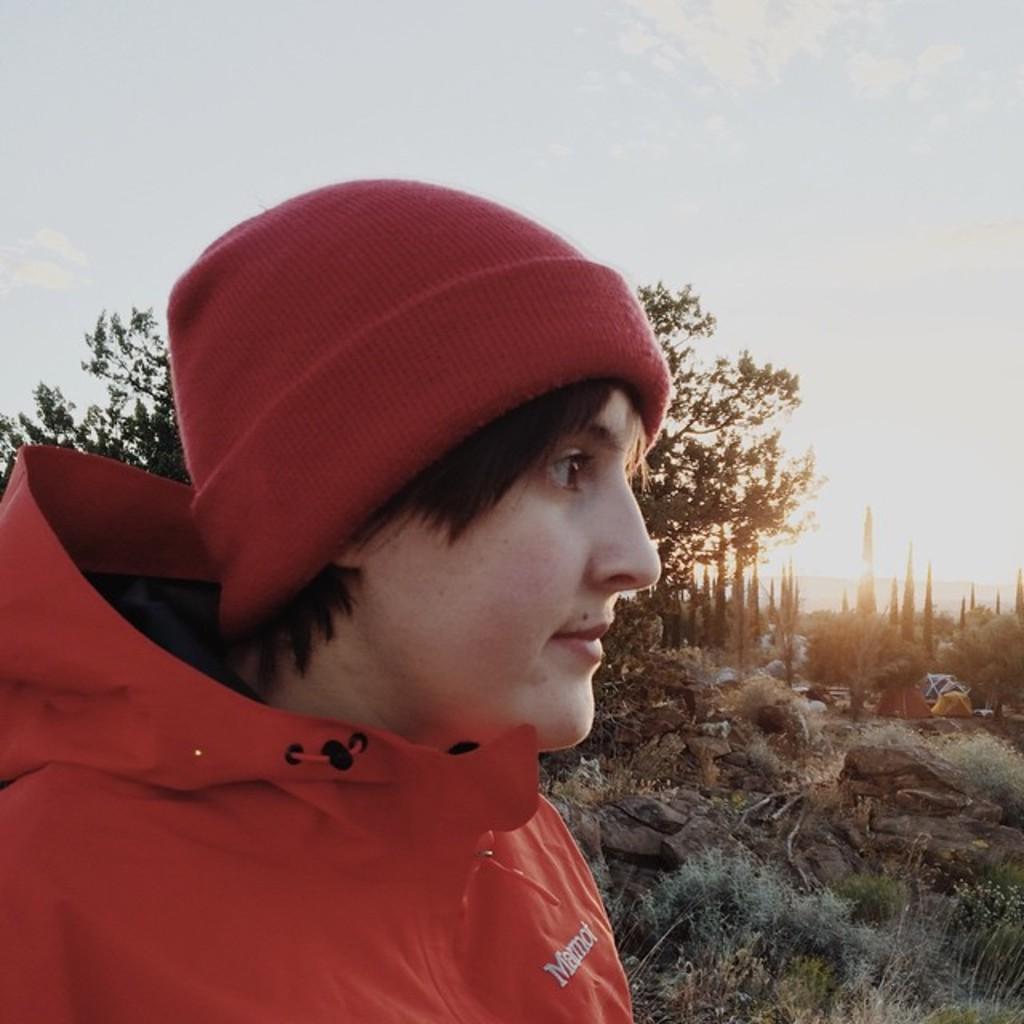How would you summarize this image in a sentence or two? In this image I can see the person with the dress and cap. In the background I can see the grass, many trees and the sky. To the right I can see few tents. 